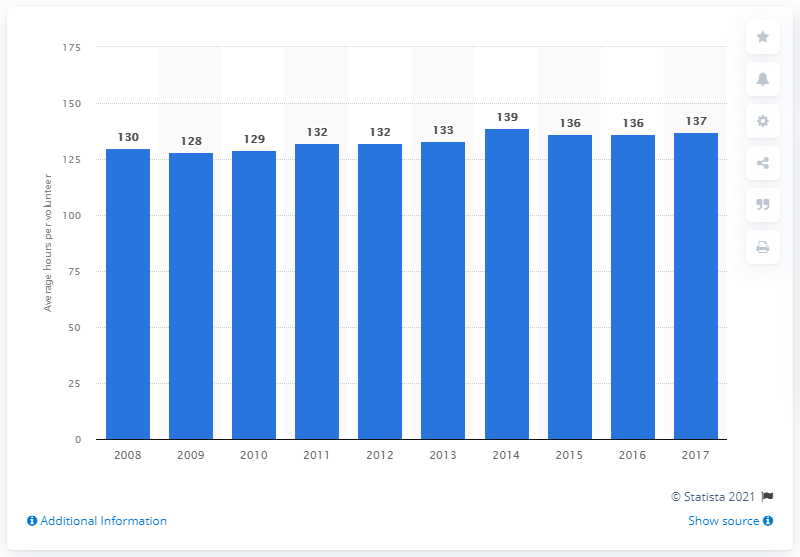Give some essential details in this illustration. In 2017, the average number of hours volunteered per volunteer in the United States was 137 hours. 